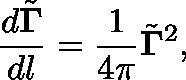<formula> <loc_0><loc_0><loc_500><loc_500>\frac { d \tilde { \Gamma } } { d l } = \frac { 1 } { 4 \pi } \tilde { \Gamma } ^ { 2 } ,</formula> 